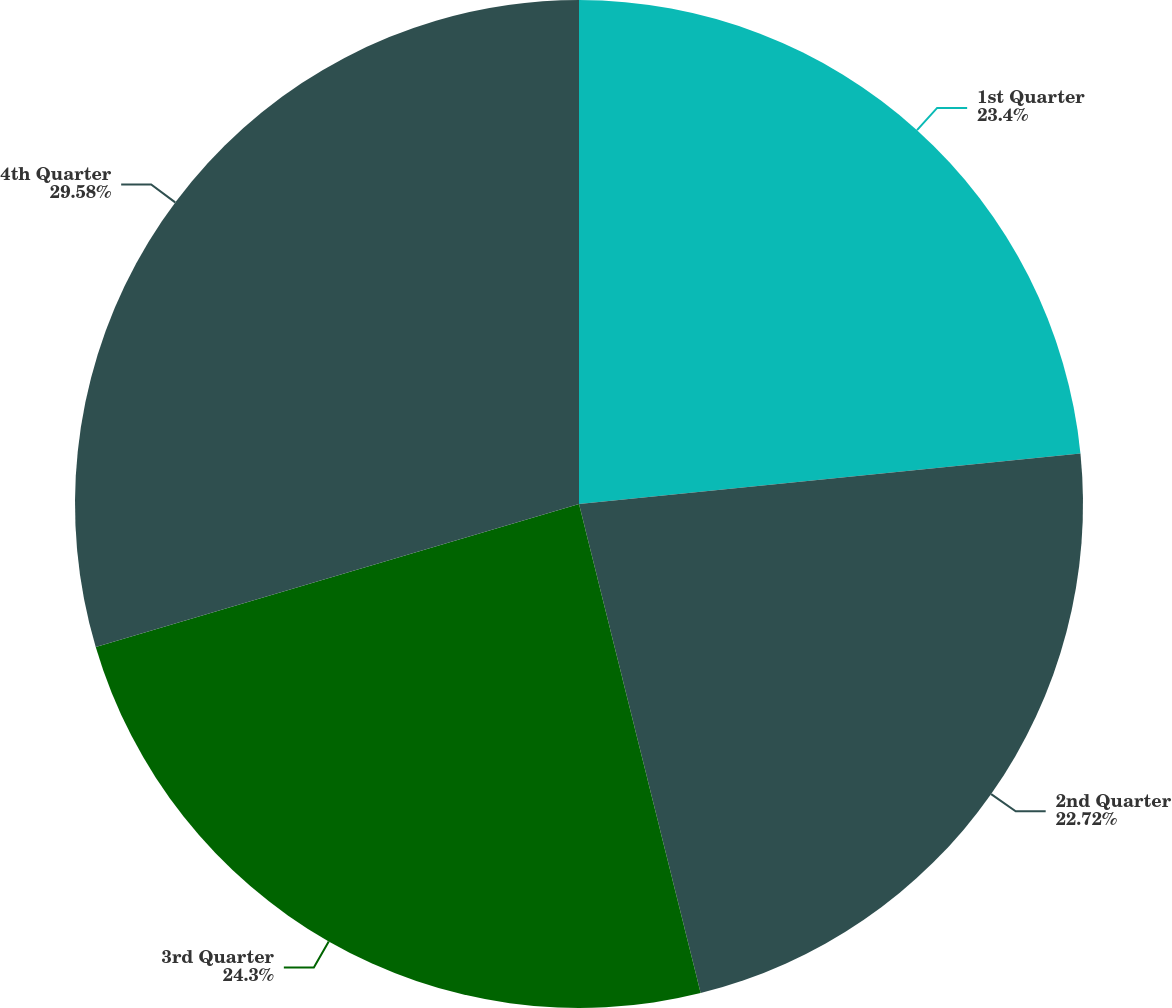Convert chart to OTSL. <chart><loc_0><loc_0><loc_500><loc_500><pie_chart><fcel>1st Quarter<fcel>2nd Quarter<fcel>3rd Quarter<fcel>4th Quarter<nl><fcel>23.4%<fcel>22.72%<fcel>24.3%<fcel>29.58%<nl></chart> 